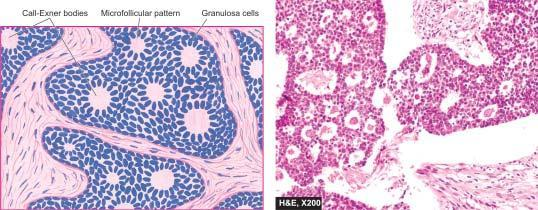what did granulosa cell tumour show?
Answer the question using a single word or phrase. The shows the characteristic submucosal cambium layer of cells 